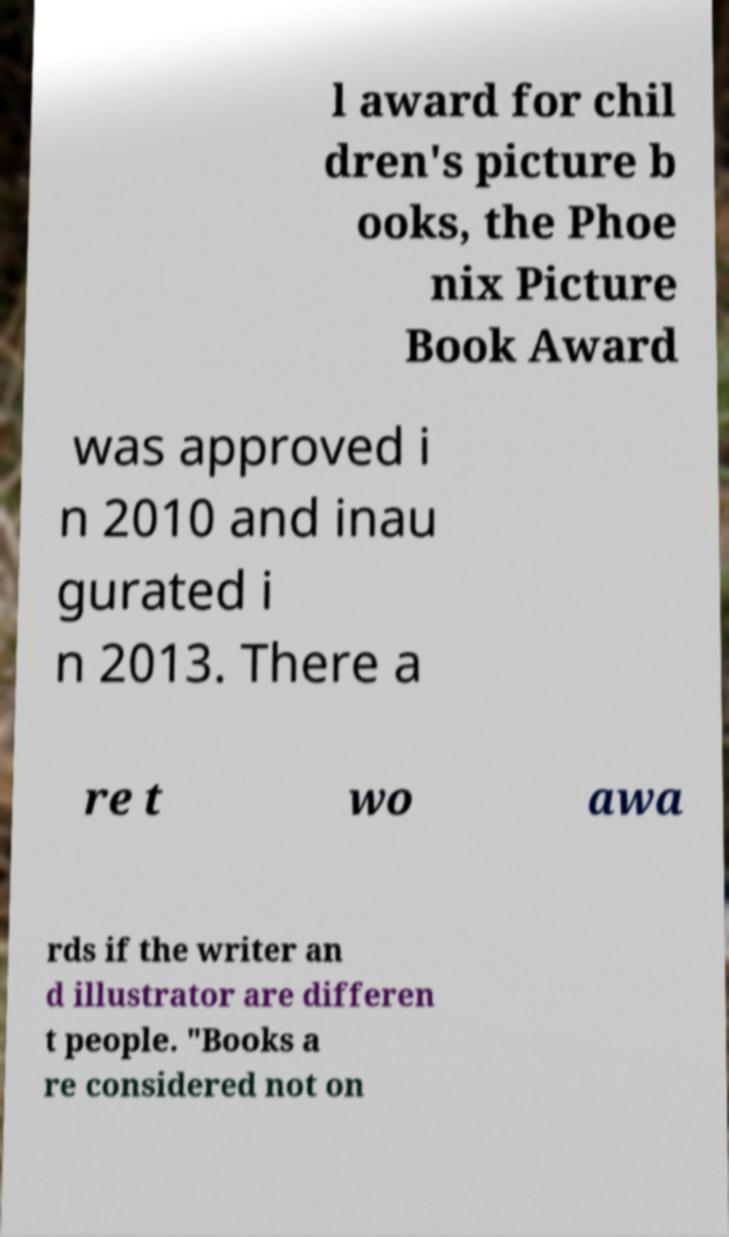For documentation purposes, I need the text within this image transcribed. Could you provide that? l award for chil dren's picture b ooks, the Phoe nix Picture Book Award was approved i n 2010 and inau gurated i n 2013. There a re t wo awa rds if the writer an d illustrator are differen t people. "Books a re considered not on 